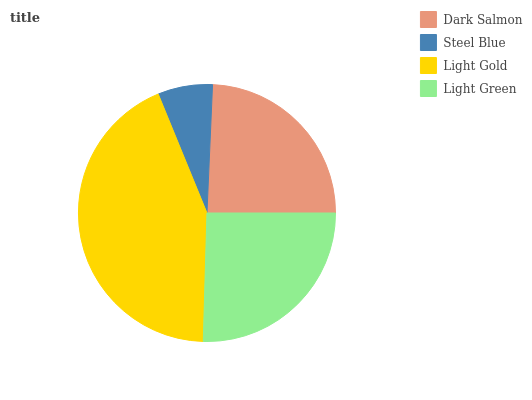Is Steel Blue the minimum?
Answer yes or no. Yes. Is Light Gold the maximum?
Answer yes or no. Yes. Is Light Gold the minimum?
Answer yes or no. No. Is Steel Blue the maximum?
Answer yes or no. No. Is Light Gold greater than Steel Blue?
Answer yes or no. Yes. Is Steel Blue less than Light Gold?
Answer yes or no. Yes. Is Steel Blue greater than Light Gold?
Answer yes or no. No. Is Light Gold less than Steel Blue?
Answer yes or no. No. Is Light Green the high median?
Answer yes or no. Yes. Is Dark Salmon the low median?
Answer yes or no. Yes. Is Steel Blue the high median?
Answer yes or no. No. Is Steel Blue the low median?
Answer yes or no. No. 